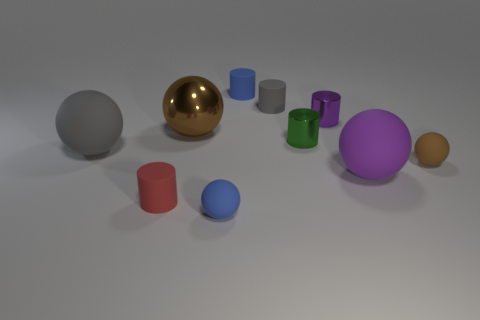Subtract all gray balls. How many balls are left? 4 Subtract 1 cylinders. How many cylinders are left? 4 Subtract all gray balls. How many balls are left? 4 Subtract all green spheres. Subtract all purple cylinders. How many spheres are left? 5 Add 4 big purple balls. How many big purple balls are left? 5 Add 5 large gray matte balls. How many large gray matte balls exist? 6 Subtract 1 brown balls. How many objects are left? 9 Subtract all red matte cylinders. Subtract all brown metal objects. How many objects are left? 8 